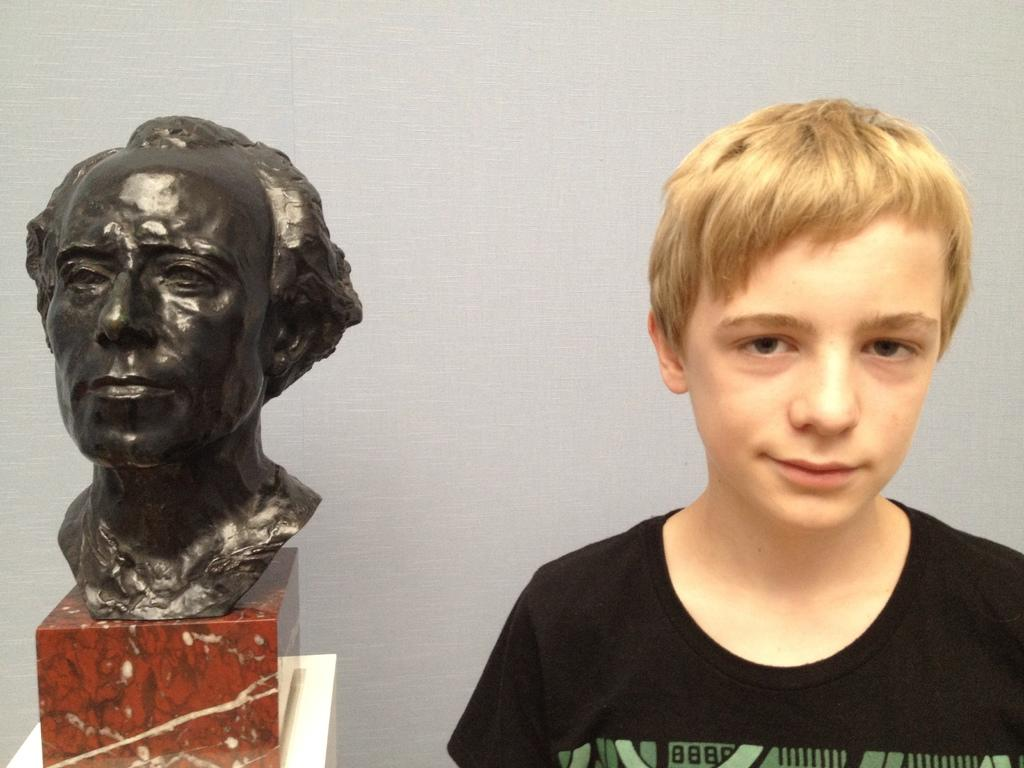Who is the main subject in the image? There is a boy in the image. What is the boy wearing? The boy is wearing a black t-shirt. What other object can be seen in the image? There is a sculpture of a man in the image. What is visible in the background of the image? There is a wall in the background of the image. What type of kettle is being used to stimulate the boy's nerves in the image? There is no kettle or nerve stimulation present in the image; it features a boy wearing a black t-shirt and a sculpture of a man. 